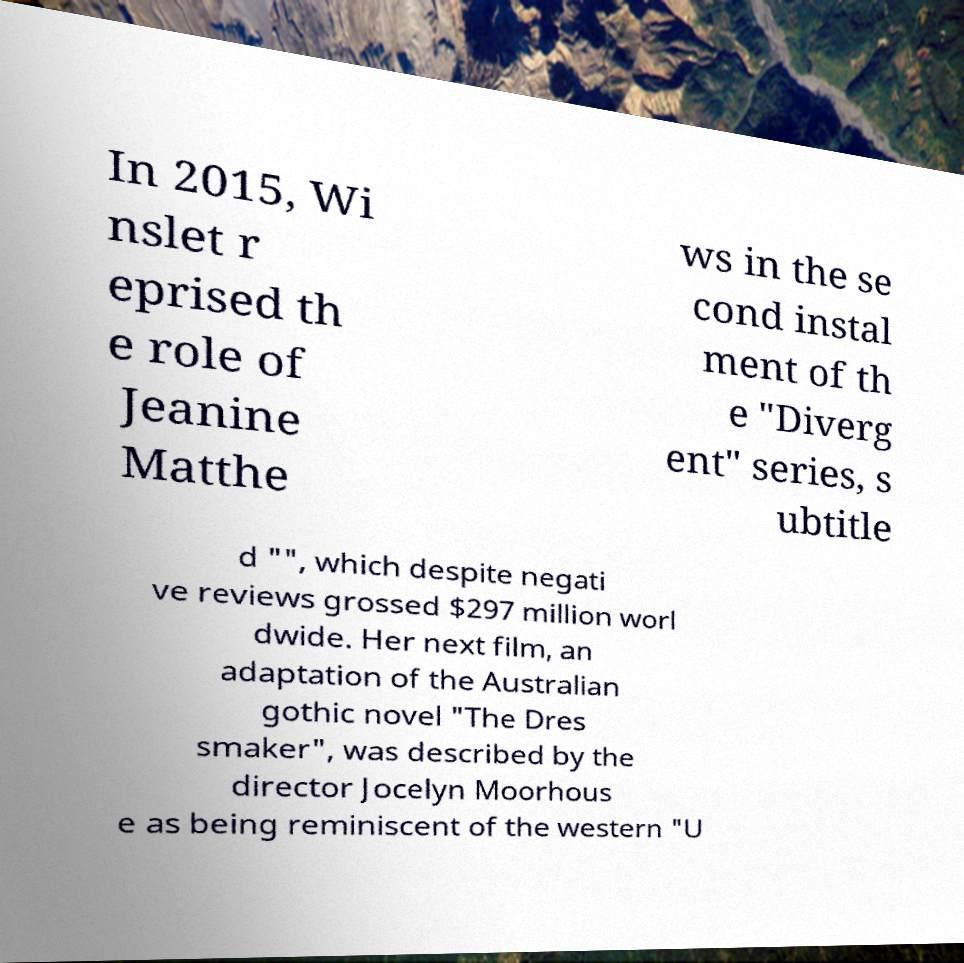There's text embedded in this image that I need extracted. Can you transcribe it verbatim? In 2015, Wi nslet r eprised th e role of Jeanine Matthe ws in the se cond instal ment of th e "Diverg ent" series, s ubtitle d "", which despite negati ve reviews grossed $297 million worl dwide. Her next film, an adaptation of the Australian gothic novel "The Dres smaker", was described by the director Jocelyn Moorhous e as being reminiscent of the western "U 